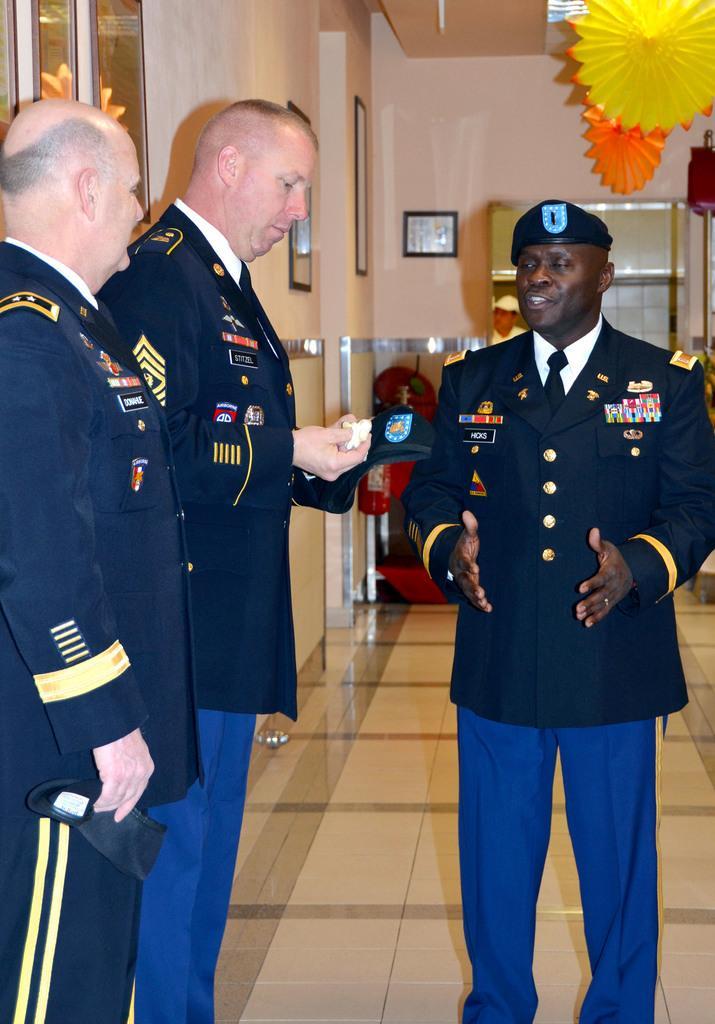In one or two sentences, can you explain what this image depicts? In the image we can see there are men standing and there is a man holding an object in his hand. There are decorative items hanging from the top and there are photo frames on the wall. 